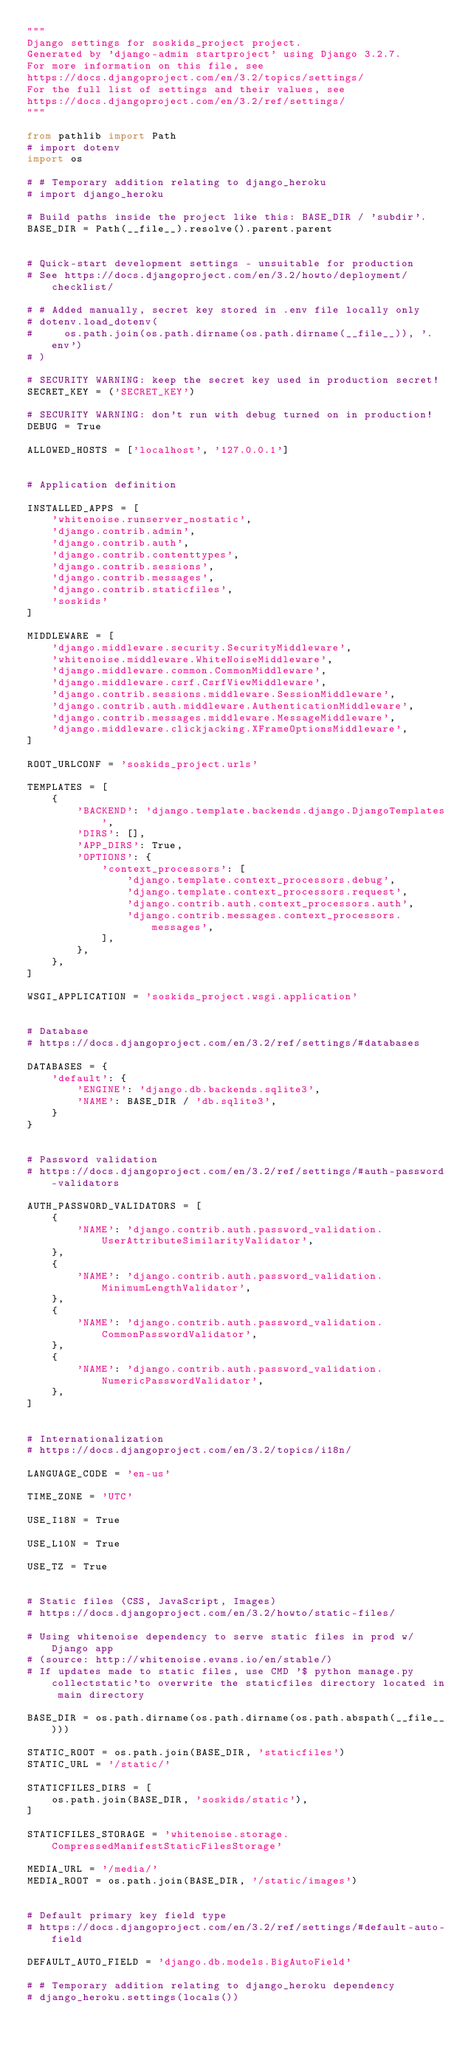<code> <loc_0><loc_0><loc_500><loc_500><_Python_>"""
Django settings for soskids_project project.
Generated by 'django-admin startproject' using Django 3.2.7.
For more information on this file, see
https://docs.djangoproject.com/en/3.2/topics/settings/
For the full list of settings and their values, see
https://docs.djangoproject.com/en/3.2/ref/settings/
"""

from pathlib import Path
# import dotenv 
import os

# # Temporary addition relating to django_heroku
# import django_heroku

# Build paths inside the project like this: BASE_DIR / 'subdir'.
BASE_DIR = Path(__file__).resolve().parent.parent


# Quick-start development settings - unsuitable for production
# See https://docs.djangoproject.com/en/3.2/howto/deployment/checklist/

# # Added manually, secret key stored in .env file locally only 
# dotenv.load_dotenv(
#     os.path.join(os.path.dirname(os.path.dirname(__file__)), '.env')
# )

# SECURITY WARNING: keep the secret key used in production secret!
SECRET_KEY = ('SECRET_KEY')

# SECURITY WARNING: don't run with debug turned on in production!
DEBUG = True

ALLOWED_HOSTS = ['localhost', '127.0.0.1']


# Application definition

INSTALLED_APPS = [
    'whitenoise.runserver_nostatic',
    'django.contrib.admin',
    'django.contrib.auth',
    'django.contrib.contenttypes',
    'django.contrib.sessions',
    'django.contrib.messages',
    'django.contrib.staticfiles',
    'soskids'
]

MIDDLEWARE = [
    'django.middleware.security.SecurityMiddleware',
    'whitenoise.middleware.WhiteNoiseMiddleware',
    'django.middleware.common.CommonMiddleware',
    'django.middleware.csrf.CsrfViewMiddleware',
    'django.contrib.sessions.middleware.SessionMiddleware',
    'django.contrib.auth.middleware.AuthenticationMiddleware',
    'django.contrib.messages.middleware.MessageMiddleware',
    'django.middleware.clickjacking.XFrameOptionsMiddleware',
]

ROOT_URLCONF = 'soskids_project.urls'

TEMPLATES = [
    {
        'BACKEND': 'django.template.backends.django.DjangoTemplates',
        'DIRS': [],
        'APP_DIRS': True,
        'OPTIONS': {
            'context_processors': [
                'django.template.context_processors.debug',
                'django.template.context_processors.request',
                'django.contrib.auth.context_processors.auth',
                'django.contrib.messages.context_processors.messages',
            ],
        },
    },
]

WSGI_APPLICATION = 'soskids_project.wsgi.application'


# Database
# https://docs.djangoproject.com/en/3.2/ref/settings/#databases

DATABASES = {
    'default': {
        'ENGINE': 'django.db.backends.sqlite3',
        'NAME': BASE_DIR / 'db.sqlite3',
    }
}


# Password validation
# https://docs.djangoproject.com/en/3.2/ref/settings/#auth-password-validators

AUTH_PASSWORD_VALIDATORS = [
    {
        'NAME': 'django.contrib.auth.password_validation.UserAttributeSimilarityValidator',
    },
    {
        'NAME': 'django.contrib.auth.password_validation.MinimumLengthValidator',
    },
    {
        'NAME': 'django.contrib.auth.password_validation.CommonPasswordValidator',
    },
    {
        'NAME': 'django.contrib.auth.password_validation.NumericPasswordValidator',
    },
]


# Internationalization
# https://docs.djangoproject.com/en/3.2/topics/i18n/

LANGUAGE_CODE = 'en-us'

TIME_ZONE = 'UTC'

USE_I18N = True

USE_L10N = True

USE_TZ = True


# Static files (CSS, JavaScript, Images)
# https://docs.djangoproject.com/en/3.2/howto/static-files/

# Using whitenoise dependency to serve static files in prod w/ Django app
# (source: http://whitenoise.evans.io/en/stable/)
# If updates made to static files, use CMD '$ python manage.py collectstatic'to overwrite the staticfiles directory located in main directory

BASE_DIR = os.path.dirname(os.path.dirname(os.path.abspath(__file__)))

STATIC_ROOT = os.path.join(BASE_DIR, 'staticfiles')
STATIC_URL = '/static/'

STATICFILES_DIRS = [
    os.path.join(BASE_DIR, 'soskids/static'),
]

STATICFILES_STORAGE = 'whitenoise.storage.CompressedManifestStaticFilesStorage'

MEDIA_URL = '/media/'
MEDIA_ROOT = os.path.join(BASE_DIR, '/static/images')


# Default primary key field type
# https://docs.djangoproject.com/en/3.2/ref/settings/#default-auto-field

DEFAULT_AUTO_FIELD = 'django.db.models.BigAutoField'

# # Temporary addition relating to django_heroku dependency
# django_heroku.settings(locals()) </code> 